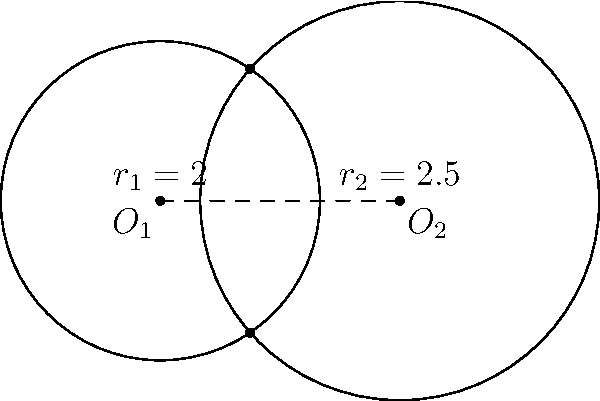Two circles with centers $O_1(0,0)$ and $O_2(3,0)$ have radii $r_1 = 2$ and $r_2 = 2.5$ respectively. Calculate the area of their overlap region, rounding your answer to two decimal places. Let's approach this step-by-step:

1) First, we need to find the distance between the centers:
   $d = 3$ (given in the coordinates)

2) We can use the formula for the area of intersection of two circles:

   $A = r_1^2 \arccos(\frac{d^2 + r_1^2 - r_2^2}{2dr_1}) + r_2^2 \arccos(\frac{d^2 + r_2^2 - r_1^2}{2dr_2}) - \frac{1}{2}\sqrt{(-d+r_1+r_2)(d+r_1-r_2)(d-r_1+r_2)(d+r_1+r_2)}$

3) Let's substitute our values:
   $r_1 = 2$, $r_2 = 2.5$, $d = 3$

4) Calculate each part:
   
   $\arccos(\frac{3^2 + 2^2 - 2.5^2}{2 \cdot 3 \cdot 2}) = \arccos(0.3125) = 1.2490$
   
   $\arccos(\frac{3^2 + 2.5^2 - 2^2}{2 \cdot 3 \cdot 2.5}) = \arccos(0.55) = 0.9856$
   
   $\sqrt{(-3+2+2.5)(3+2-2.5)(3-2+2.5)(3+2+2.5)} = \sqrt{1.5 \cdot 2.5 \cdot 3.5 \cdot 7.5} = 4.7871$

5) Now, let's put it all together:

   $A = 2^2 \cdot 1.2490 + 2.5^2 \cdot 0.9856 - \frac{1}{2} \cdot 4.7871$
   
   $A = 4.9960 + 6.1600 - 2.3936 = 8.7624$

6) Rounding to two decimal places:
   $A \approx 8.76$
Answer: $8.76$ square units 